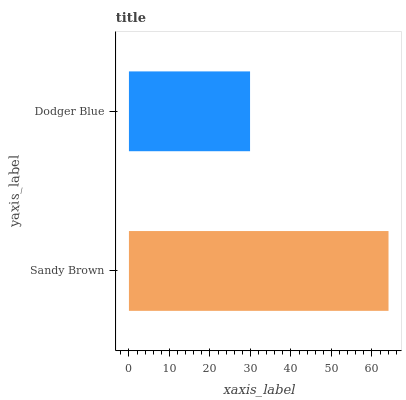Is Dodger Blue the minimum?
Answer yes or no. Yes. Is Sandy Brown the maximum?
Answer yes or no. Yes. Is Dodger Blue the maximum?
Answer yes or no. No. Is Sandy Brown greater than Dodger Blue?
Answer yes or no. Yes. Is Dodger Blue less than Sandy Brown?
Answer yes or no. Yes. Is Dodger Blue greater than Sandy Brown?
Answer yes or no. No. Is Sandy Brown less than Dodger Blue?
Answer yes or no. No. Is Sandy Brown the high median?
Answer yes or no. Yes. Is Dodger Blue the low median?
Answer yes or no. Yes. Is Dodger Blue the high median?
Answer yes or no. No. Is Sandy Brown the low median?
Answer yes or no. No. 